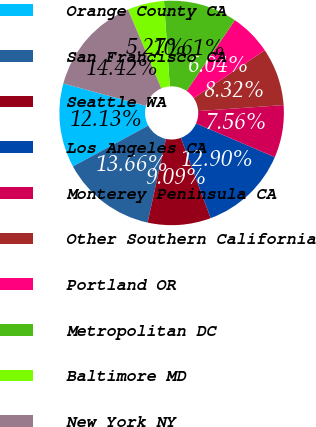<chart> <loc_0><loc_0><loc_500><loc_500><pie_chart><fcel>Orange County CA<fcel>San Francisco CA<fcel>Seattle WA<fcel>Los Angeles CA<fcel>Monterey Peninsula CA<fcel>Other Southern California<fcel>Portland OR<fcel>Metropolitan DC<fcel>Baltimore MD<fcel>New York NY<nl><fcel>12.13%<fcel>13.66%<fcel>9.09%<fcel>12.9%<fcel>7.56%<fcel>8.32%<fcel>6.04%<fcel>10.61%<fcel>5.27%<fcel>14.42%<nl></chart> 